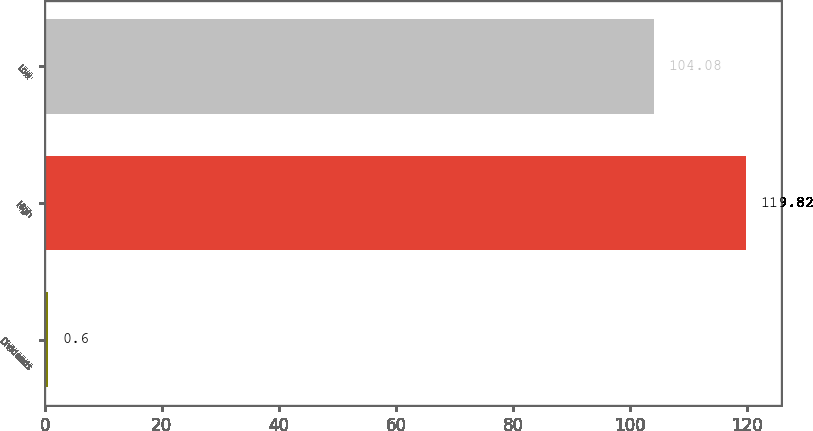Convert chart. <chart><loc_0><loc_0><loc_500><loc_500><bar_chart><fcel>Dividends<fcel>High<fcel>Low<nl><fcel>0.6<fcel>119.82<fcel>104.08<nl></chart> 